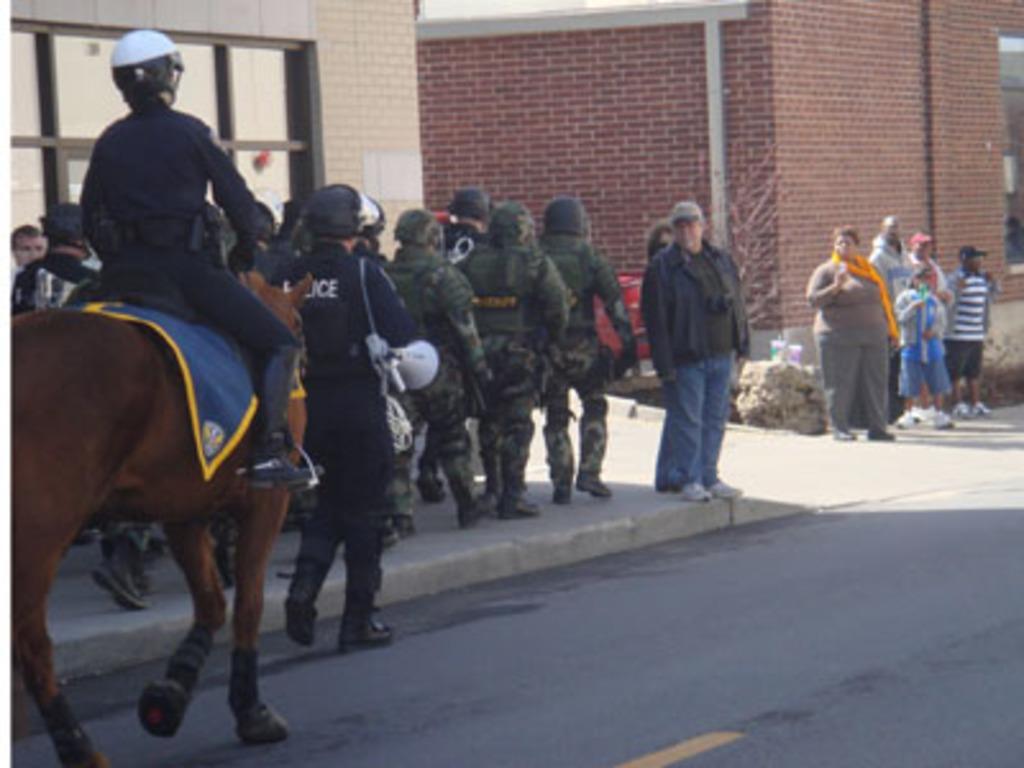Please provide a concise description of this image. There are many people walking on the sidewalk. A person wearing helmet is sitting on a horse and riding. Another person is holding a megaphone. In the background there are buildings with brick wall. Also some people are standing on the sidewalk. 